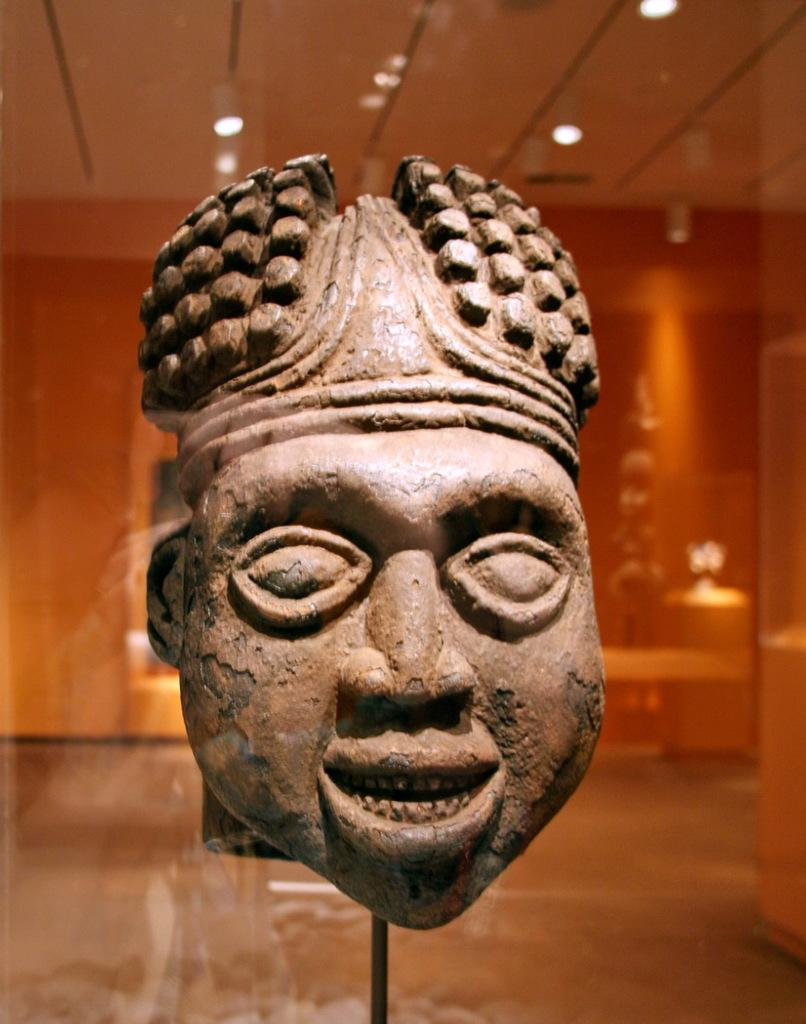What is the main subject in the image? There is a sculpture in the image. What can be seen near the sculpture? There is a rod in the image. What is visible in the background of the image? There are lights on the ceiling, a board, and a wall in the background of the image. Are there any other objects visible in the background? Yes, there are other objects in the background of the image. What type of meat is hanging from the sculpture in the image? There is no meat present in the image; it features a sculpture and a rod. How quiet is the environment in the image? The provided facts do not give any information about the noise level in the image, so it cannot be determined from the image. 